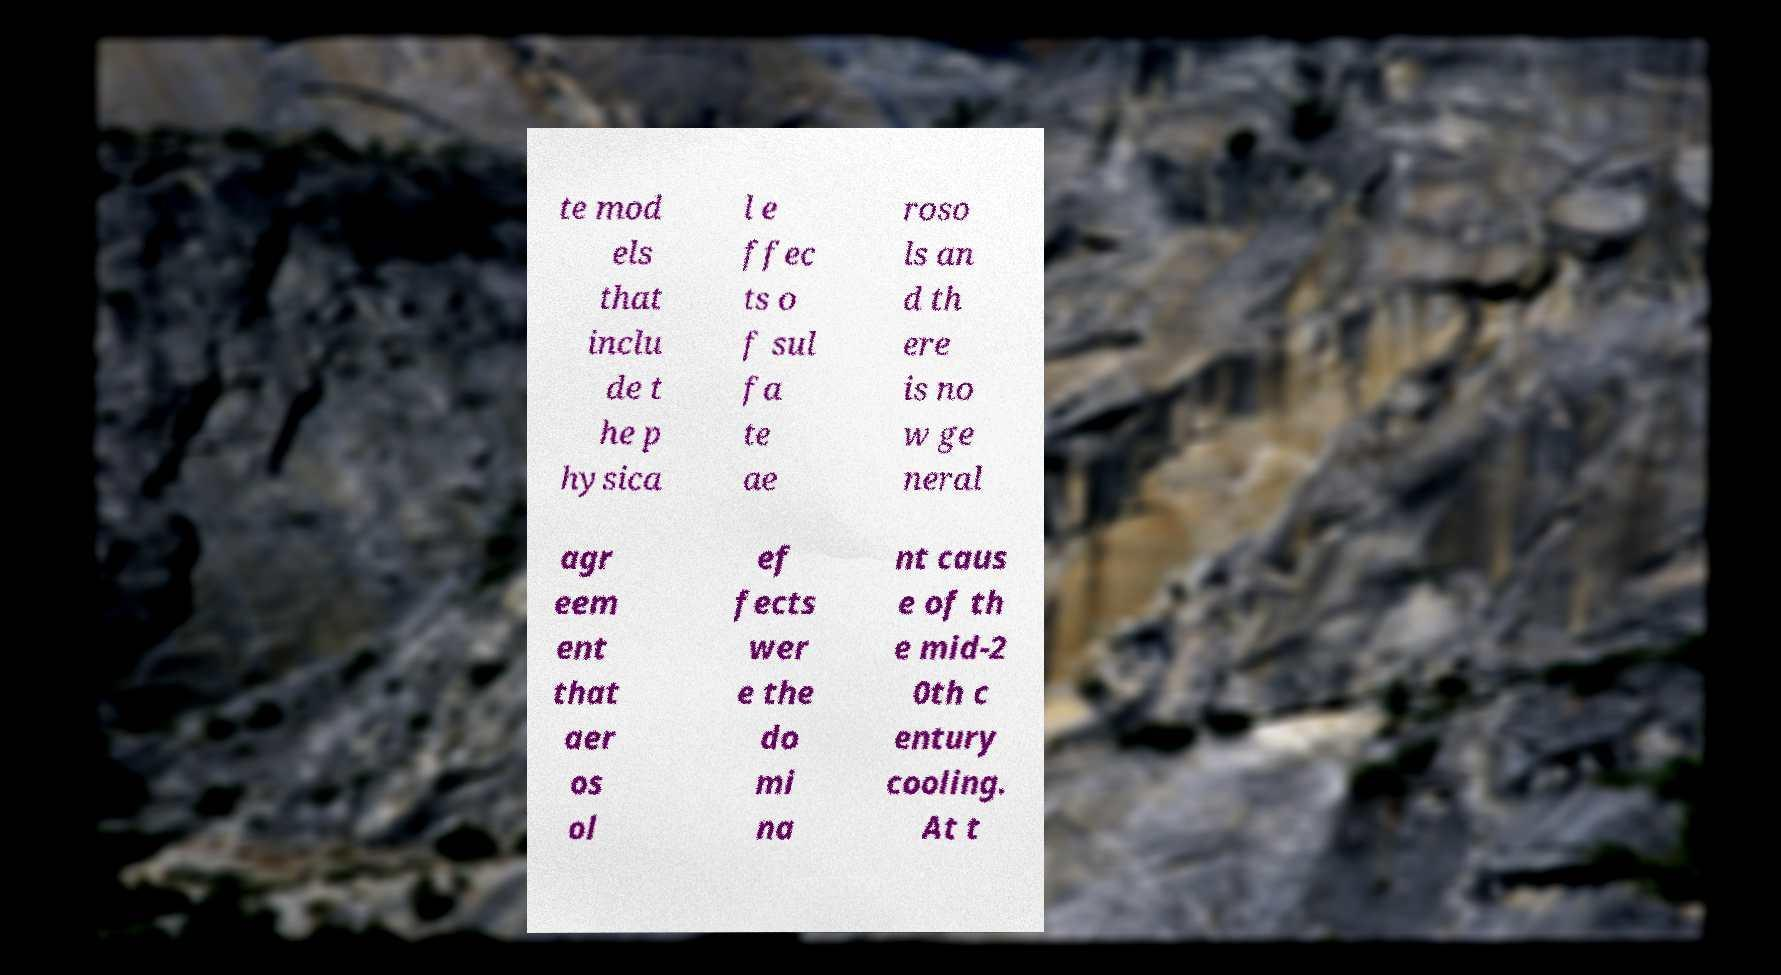Please read and relay the text visible in this image. What does it say? te mod els that inclu de t he p hysica l e ffec ts o f sul fa te ae roso ls an d th ere is no w ge neral agr eem ent that aer os ol ef fects wer e the do mi na nt caus e of th e mid-2 0th c entury cooling. At t 